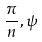<formula> <loc_0><loc_0><loc_500><loc_500>\frac { \pi } { n } , \psi</formula> 